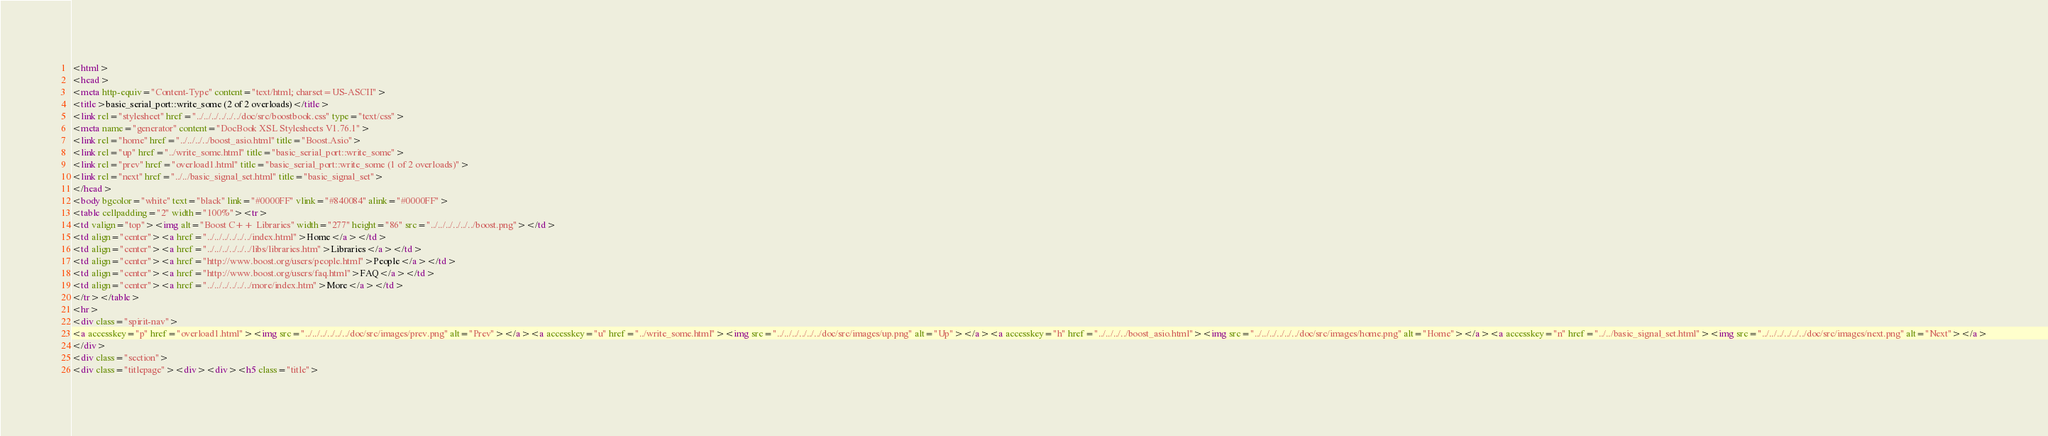Convert code to text. <code><loc_0><loc_0><loc_500><loc_500><_HTML_><html>
<head>
<meta http-equiv="Content-Type" content="text/html; charset=US-ASCII">
<title>basic_serial_port::write_some (2 of 2 overloads)</title>
<link rel="stylesheet" href="../../../../../../doc/src/boostbook.css" type="text/css">
<meta name="generator" content="DocBook XSL Stylesheets V1.76.1">
<link rel="home" href="../../../../boost_asio.html" title="Boost.Asio">
<link rel="up" href="../write_some.html" title="basic_serial_port::write_some">
<link rel="prev" href="overload1.html" title="basic_serial_port::write_some (1 of 2 overloads)">
<link rel="next" href="../../basic_signal_set.html" title="basic_signal_set">
</head>
<body bgcolor="white" text="black" link="#0000FF" vlink="#840084" alink="#0000FF">
<table cellpadding="2" width="100%"><tr>
<td valign="top"><img alt="Boost C++ Libraries" width="277" height="86" src="../../../../../../boost.png"></td>
<td align="center"><a href="../../../../../../index.html">Home</a></td>
<td align="center"><a href="../../../../../../libs/libraries.htm">Libraries</a></td>
<td align="center"><a href="http://www.boost.org/users/people.html">People</a></td>
<td align="center"><a href="http://www.boost.org/users/faq.html">FAQ</a></td>
<td align="center"><a href="../../../../../../more/index.htm">More</a></td>
</tr></table>
<hr>
<div class="spirit-nav">
<a accesskey="p" href="overload1.html"><img src="../../../../../../doc/src/images/prev.png" alt="Prev"></a><a accesskey="u" href="../write_some.html"><img src="../../../../../../doc/src/images/up.png" alt="Up"></a><a accesskey="h" href="../../../../boost_asio.html"><img src="../../../../../../doc/src/images/home.png" alt="Home"></a><a accesskey="n" href="../../basic_signal_set.html"><img src="../../../../../../doc/src/images/next.png" alt="Next"></a>
</div>
<div class="section">
<div class="titlepage"><div><div><h5 class="title"></code> 